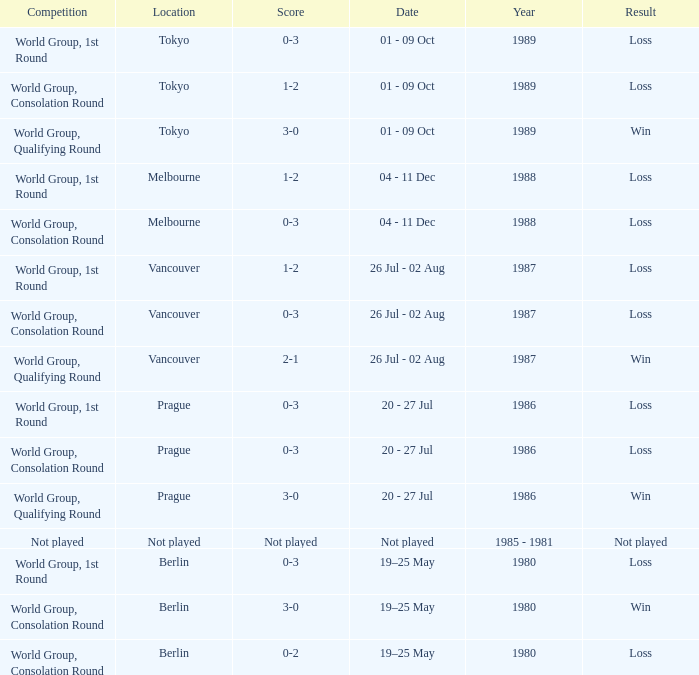Would you mind parsing the complete table? {'header': ['Competition', 'Location', 'Score', 'Date', 'Year', 'Result'], 'rows': [['World Group, 1st Round', 'Tokyo', '0-3', '01 - 09 Oct', '1989', 'Loss'], ['World Group, Consolation Round', 'Tokyo', '1-2', '01 - 09 Oct', '1989', 'Loss'], ['World Group, Qualifying Round', 'Tokyo', '3-0', '01 - 09 Oct', '1989', 'Win'], ['World Group, 1st Round', 'Melbourne', '1-2', '04 - 11 Dec', '1988', 'Loss'], ['World Group, Consolation Round', 'Melbourne', '0-3', '04 - 11 Dec', '1988', 'Loss'], ['World Group, 1st Round', 'Vancouver', '1-2', '26 Jul - 02 Aug', '1987', 'Loss'], ['World Group, Consolation Round', 'Vancouver', '0-3', '26 Jul - 02 Aug', '1987', 'Loss'], ['World Group, Qualifying Round', 'Vancouver', '2-1', '26 Jul - 02 Aug', '1987', 'Win'], ['World Group, 1st Round', 'Prague', '0-3', '20 - 27 Jul', '1986', 'Loss'], ['World Group, Consolation Round', 'Prague', '0-3', '20 - 27 Jul', '1986', 'Loss'], ['World Group, Qualifying Round', 'Prague', '3-0', '20 - 27 Jul', '1986', 'Win'], ['Not played', 'Not played', 'Not played', 'Not played', '1985 - 1981', 'Not played'], ['World Group, 1st Round', 'Berlin', '0-3', '19–25 May', '1980', 'Loss'], ['World Group, Consolation Round', 'Berlin', '3-0', '19–25 May', '1980', 'Win'], ['World Group, Consolation Round', 'Berlin', '0-2', '19–25 May', '1980', 'Loss']]} What is the year when the date is not played? 1985 - 1981. 